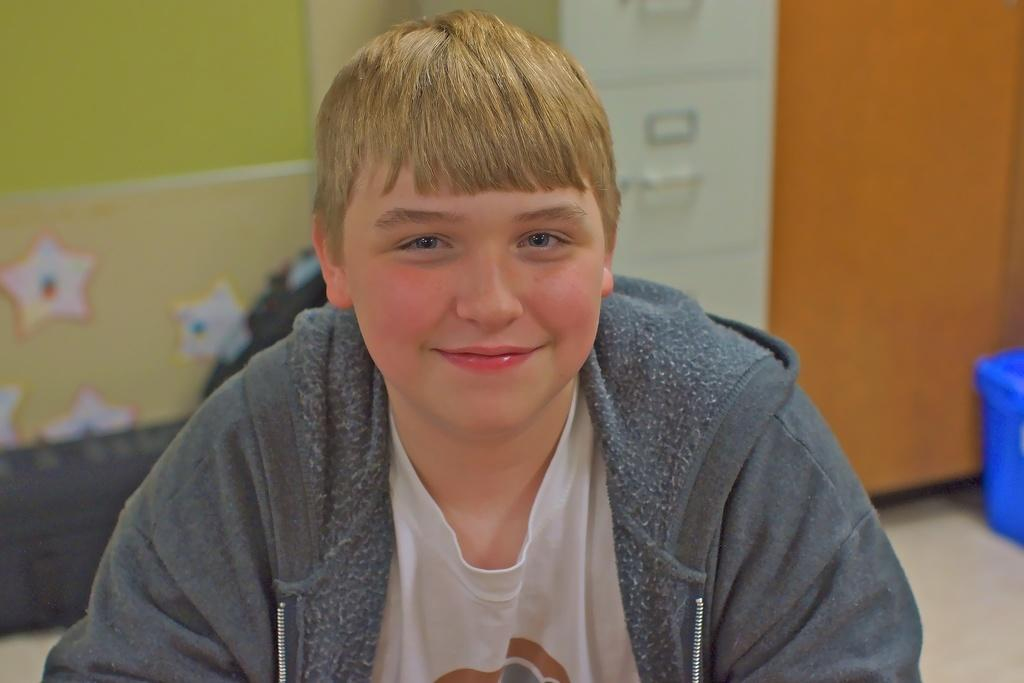Who is the main subject in the image? There is a boy in the image. What is the boy wearing? The boy is wearing a sweater. Can you describe the setting of the image? The image might have been taken in a room. What object can be seen on the right side of the image? There is a box on the right side of the image. What is the color of the box? The box is blue in color. Can you tell me how many ears the boy has in the image? The image does not show the boy's ears, so it cannot be determined from the image. 